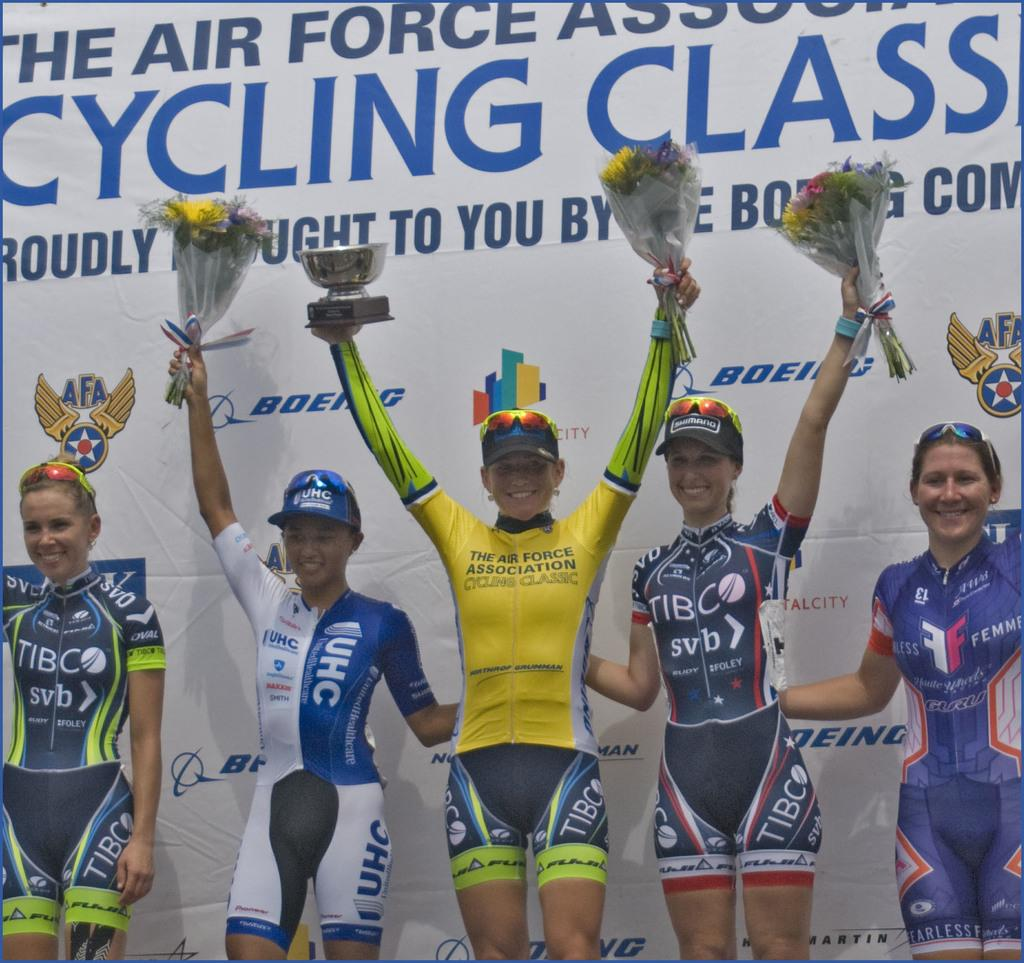<image>
Write a terse but informative summary of the picture. People posing in front of a banner which says Cycling Class. 